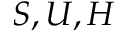Convert formula to latex. <formula><loc_0><loc_0><loc_500><loc_500>S , U , H</formula> 